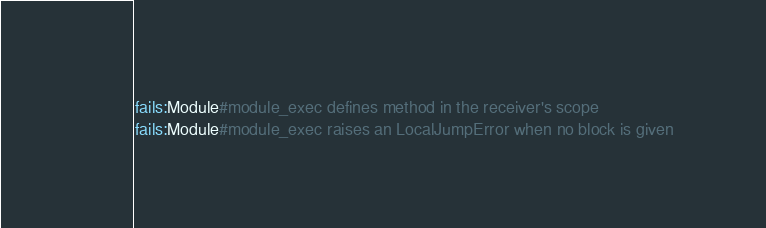Convert code to text. <code><loc_0><loc_0><loc_500><loc_500><_Ruby_>fails:Module#module_exec defines method in the receiver's scope
fails:Module#module_exec raises an LocalJumpError when no block is given
</code> 